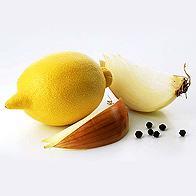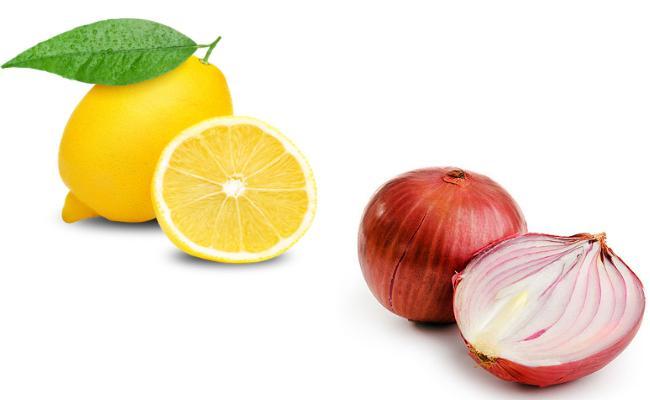The first image is the image on the left, the second image is the image on the right. For the images shown, is this caption "In one of the images there is a whole lemon next to a whole onion." true? Answer yes or no. No. The first image is the image on the left, the second image is the image on the right. For the images displayed, is the sentence "An image includes a whole onion and a half lemon, but not a whole lemon or a half onion." factually correct? Answer yes or no. No. 